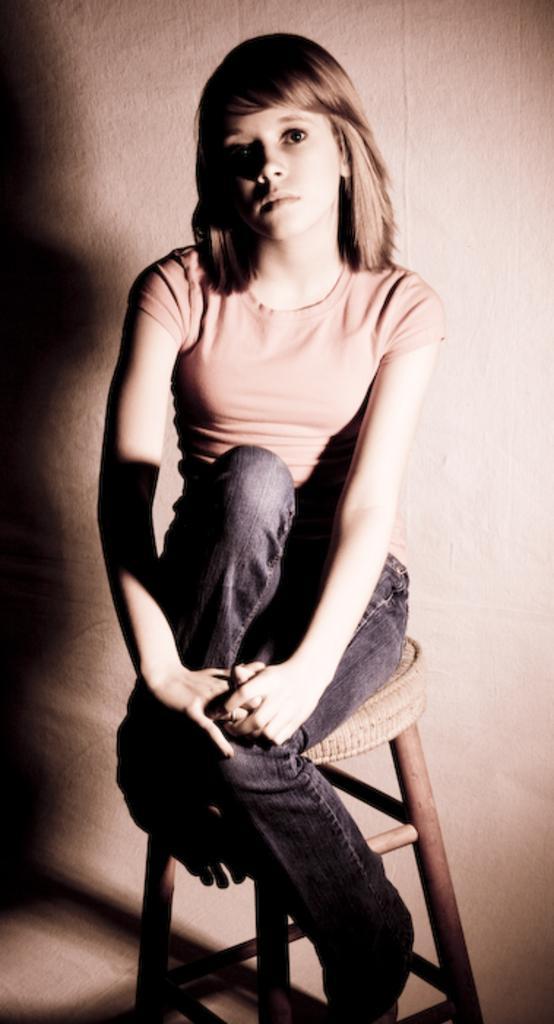How would you summarize this image in a sentence or two? In the image we can see a girl wearing clothes and the girl is sitting on the stool, this is a stool and a wall. 